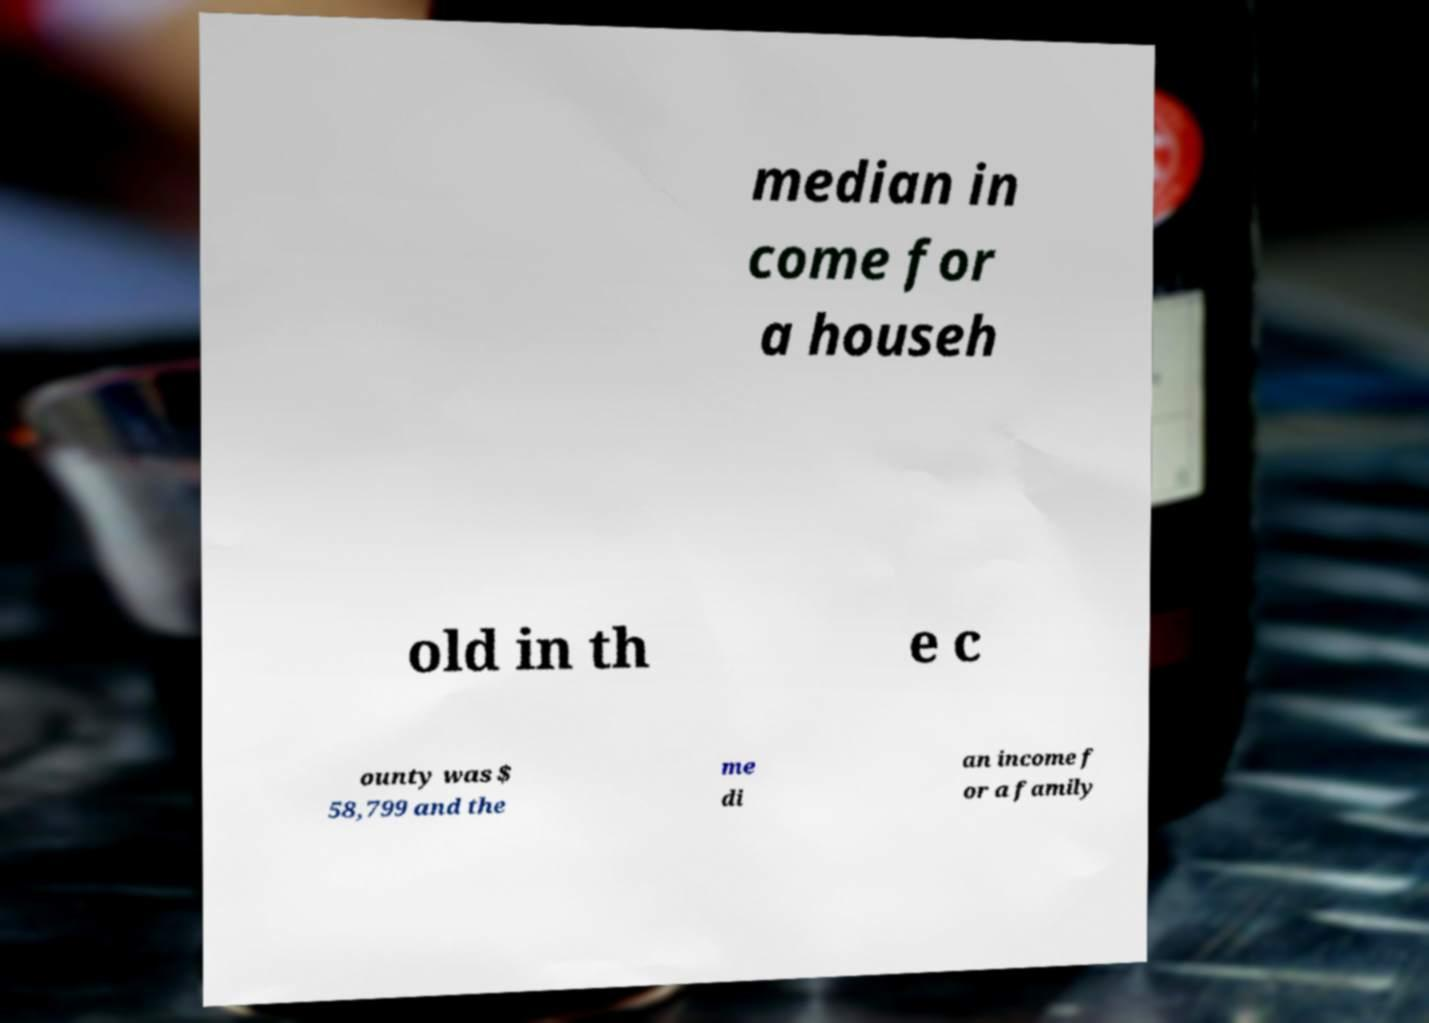Can you accurately transcribe the text from the provided image for me? median in come for a househ old in th e c ounty was $ 58,799 and the me di an income f or a family 